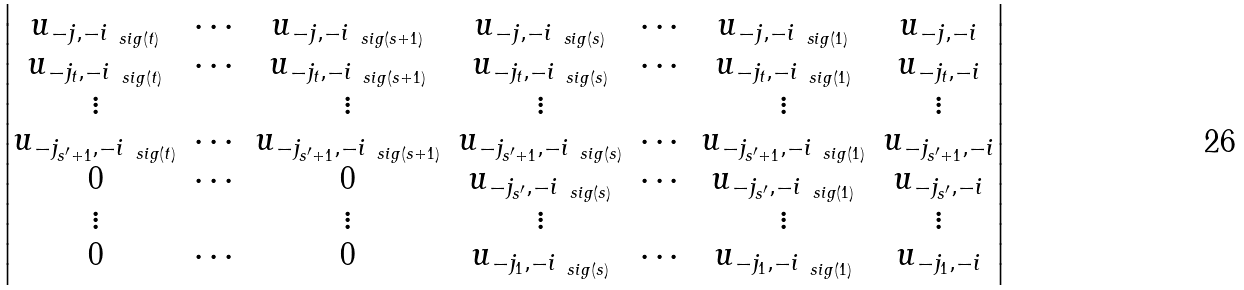Convert formula to latex. <formula><loc_0><loc_0><loc_500><loc_500>\begin{vmatrix} u _ { - j , - i _ { \ s i g ( t ) } } & \cdots & u _ { - j , - i _ { \ s i g ( s + 1 ) } } & u _ { - j , - i _ { \ s i g ( s ) } } & \cdots & u _ { - j , - i _ { \ s i g ( 1 ) } } & u _ { - j , - i } \\ u _ { - j _ { t } , - i _ { \ s i g ( t ) } } & \cdots & u _ { - j _ { t } , - i _ { \ s i g ( s + 1 ) } } & u _ { - j _ { t } , - i _ { \ s i g ( s ) } } & \cdots & u _ { - j _ { t } , - i _ { \ s i g ( 1 ) } } & u _ { - j _ { t } , - i } \\ \vdots & & \vdots & \vdots & & \vdots & \vdots \\ u _ { - j _ { s ^ { \prime } + 1 } , - i _ { \ s i g ( t ) } } & \cdots & u _ { - j _ { s ^ { \prime } + 1 } , - i _ { \ s i g ( s + 1 ) } } & u _ { - j _ { s ^ { \prime } + 1 } , - i _ { \ s i g ( s ) } } & \cdots & u _ { - j _ { s ^ { \prime } + 1 } , - i _ { \ s i g ( 1 ) } } & u _ { - j _ { s ^ { \prime } + 1 } , - i } \\ 0 & \cdots & 0 & u _ { - j _ { s ^ { \prime } } , - i _ { \ s i g ( s ) } } & \cdots & u _ { - j _ { s ^ { \prime } } , - i _ { \ s i g ( 1 ) } } & u _ { - j _ { s ^ { \prime } } , - i } \\ \vdots & & \vdots & \vdots & & \vdots & \vdots \\ 0 & \cdots & 0 & u _ { - j _ { 1 } , - i _ { \ s i g ( s ) } } & \cdots & u _ { - j _ { 1 } , - i _ { \ s i g ( 1 ) } } & u _ { - j _ { 1 } , - i } \end{vmatrix}</formula> 